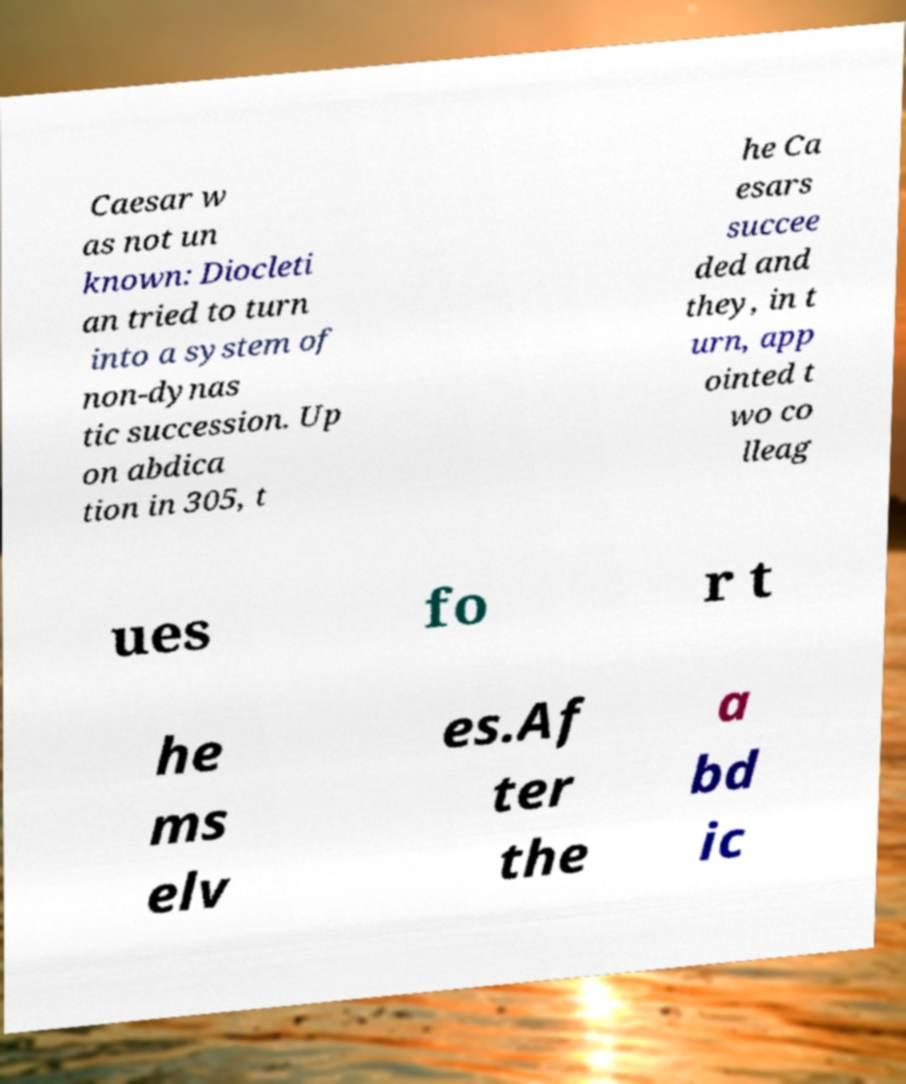Could you assist in decoding the text presented in this image and type it out clearly? Caesar w as not un known: Diocleti an tried to turn into a system of non-dynas tic succession. Up on abdica tion in 305, t he Ca esars succee ded and they, in t urn, app ointed t wo co lleag ues fo r t he ms elv es.Af ter the a bd ic 